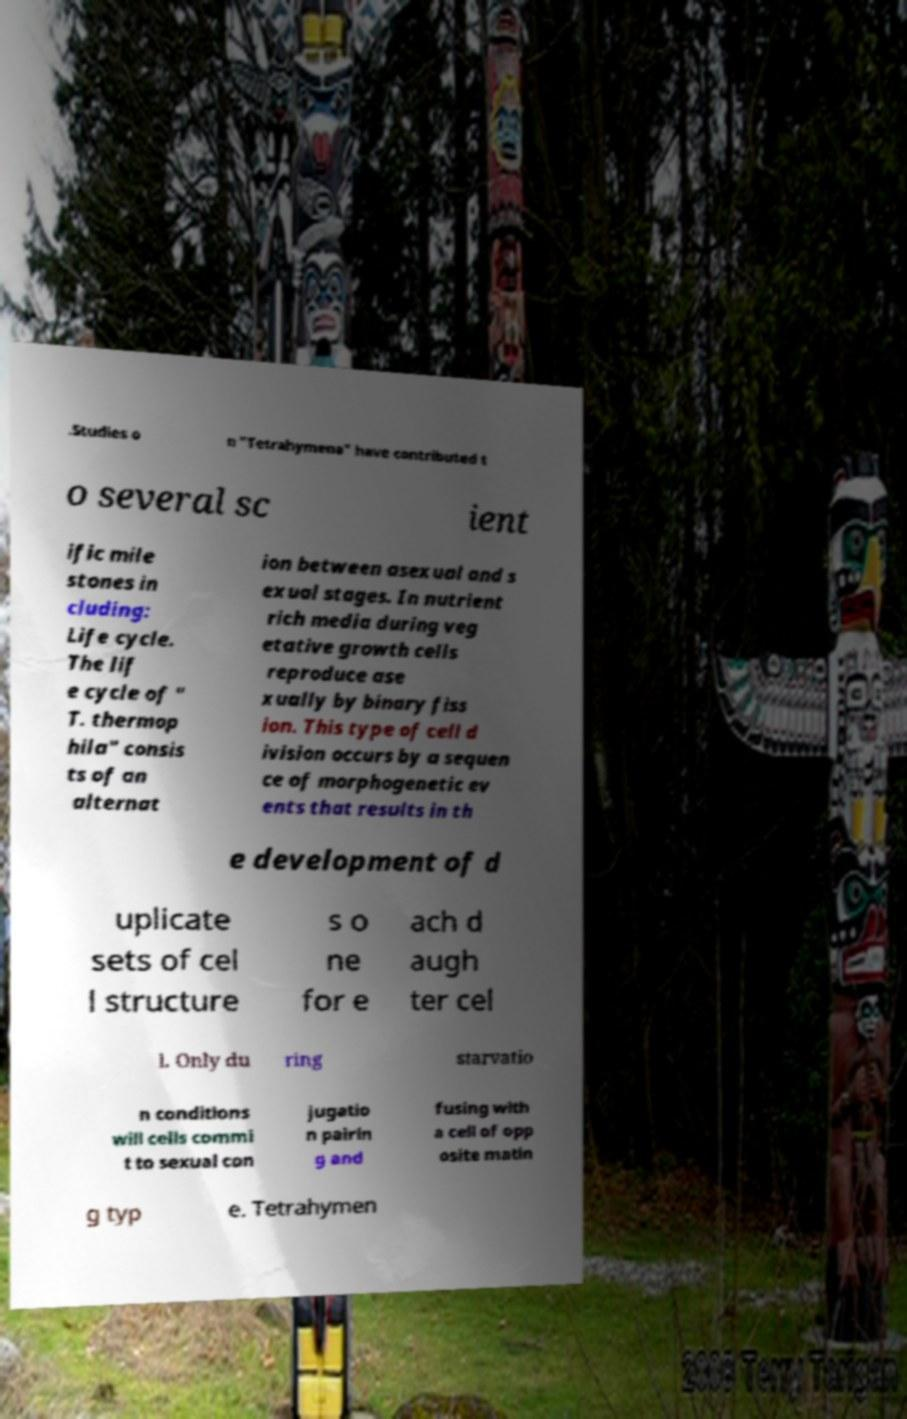For documentation purposes, I need the text within this image transcribed. Could you provide that? .Studies o n "Tetrahymena" have contributed t o several sc ient ific mile stones in cluding: Life cycle. The lif e cycle of " T. thermop hila" consis ts of an alternat ion between asexual and s exual stages. In nutrient rich media during veg etative growth cells reproduce ase xually by binary fiss ion. This type of cell d ivision occurs by a sequen ce of morphogenetic ev ents that results in th e development of d uplicate sets of cel l structure s o ne for e ach d augh ter cel l. Only du ring starvatio n conditions will cells commi t to sexual con jugatio n pairin g and fusing with a cell of opp osite matin g typ e. Tetrahymen 